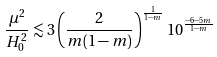Convert formula to latex. <formula><loc_0><loc_0><loc_500><loc_500>\frac { \mu ^ { 2 } } { H _ { 0 } ^ { 2 } } \lesssim 3 \left ( \frac { 2 } { m ( 1 - m ) } \right ) ^ { \frac { 1 } { 1 - m } } 1 0 ^ { \frac { - 6 - 5 m } { 1 - m } }</formula> 